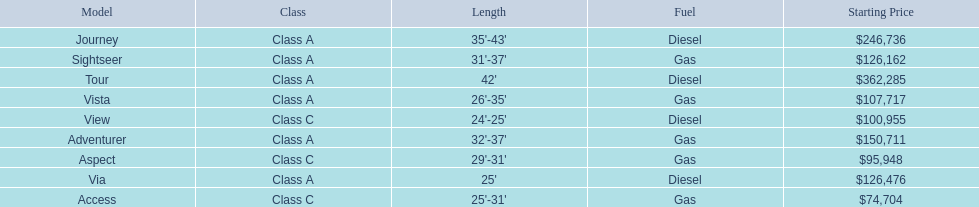What is the total number of class a models? 6. 